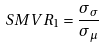Convert formula to latex. <formula><loc_0><loc_0><loc_500><loc_500>S M V R _ { 1 } = \frac { \sigma _ { \sigma } } { \sigma _ { \mu } }</formula> 